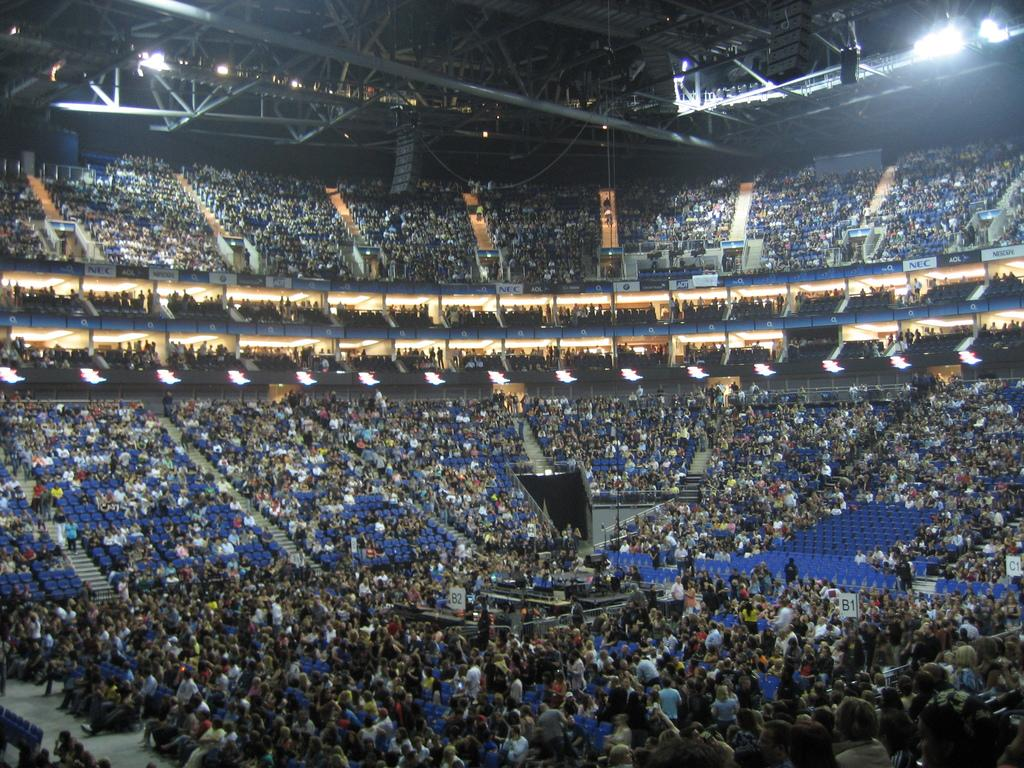What type of location is shown in the image? The image depicts an indoor stadium. Can you describe any specific features of the stadium? There is a lighting arrangement visible on the roof of the stadium. What type of tail can be seen on the appliance in the image? There is no appliance present in the image, and therefore no tail can be seen. 